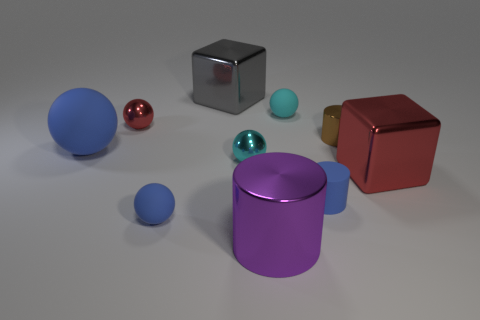Does the gray thing have the same shape as the cyan matte thing?
Offer a very short reply. No. The large rubber thing is what color?
Provide a short and direct response. Blue. How many other things are there of the same material as the large purple object?
Make the answer very short. 5. What number of cyan things are either big shiny balls or balls?
Offer a very short reply. 2. Do the cyan thing that is in front of the red sphere and the blue object to the right of the purple thing have the same shape?
Your response must be concise. No. There is a matte cylinder; is it the same color as the big shiny thing that is to the right of the brown cylinder?
Your answer should be compact. No. There is a tiny rubber object that is behind the red block; is its color the same as the large matte object?
Ensure brevity in your answer.  No. How many objects are either large brown matte cubes or tiny things that are in front of the large red block?
Your answer should be very brief. 2. What is the material of the large thing that is in front of the large sphere and on the left side of the tiny brown metallic cylinder?
Provide a short and direct response. Metal. There is a big blue sphere to the left of the cyan shiny ball; what is its material?
Give a very brief answer. Rubber. 